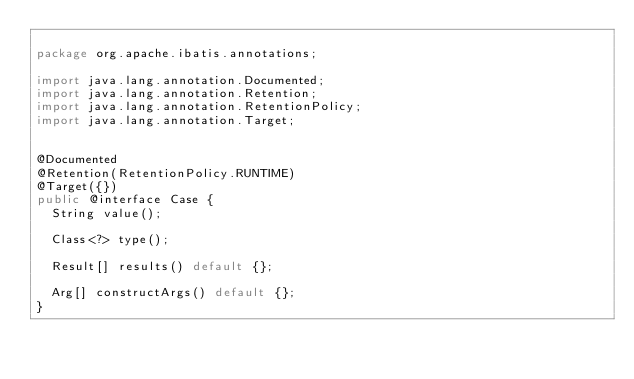<code> <loc_0><loc_0><loc_500><loc_500><_Java_>
package org.apache.ibatis.annotations;

import java.lang.annotation.Documented;
import java.lang.annotation.Retention;
import java.lang.annotation.RetentionPolicy;
import java.lang.annotation.Target;


@Documented
@Retention(RetentionPolicy.RUNTIME)
@Target({})
public @interface Case {
  String value();

  Class<?> type();

  Result[] results() default {};

  Arg[] constructArgs() default {};
}
</code> 